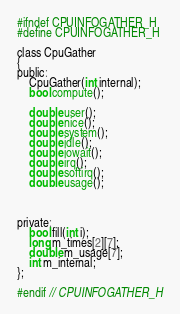<code> <loc_0><loc_0><loc_500><loc_500><_C_>#ifndef CPUINFOGATHER_H
#define CPUINFOGATHER_H

class CpuGather
{
public:
    CpuGather(int internal);
    bool compute();

    double user();
    double nice();
    double system();
    double idle();
    double iowait();
    double irq();
    double softirq();
    double usage();



private:
    bool fill(int i);
    long m_times[2][7];
    double m_usage[7];
    int m_internal;
};

#endif // CPUINFOGATHER_H
</code> 